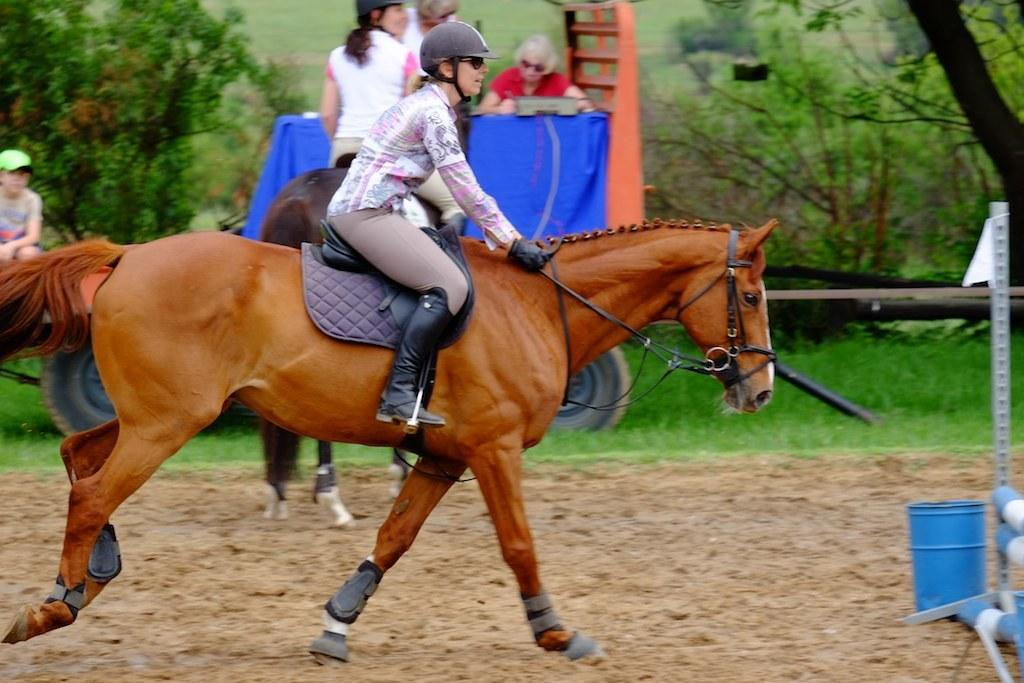What are the two people in the image doing? The two people are on horses in the image. What can be seen in the background of the image? There is a vehicle, three people, grass, and trees in the background of the image. What type of reward is the horse receiving in the image? There is no reward being given to the horse in the image. What are the people in the background using to play with the horses? There are no sticks or any other objects being used to play with the horses in the image. 